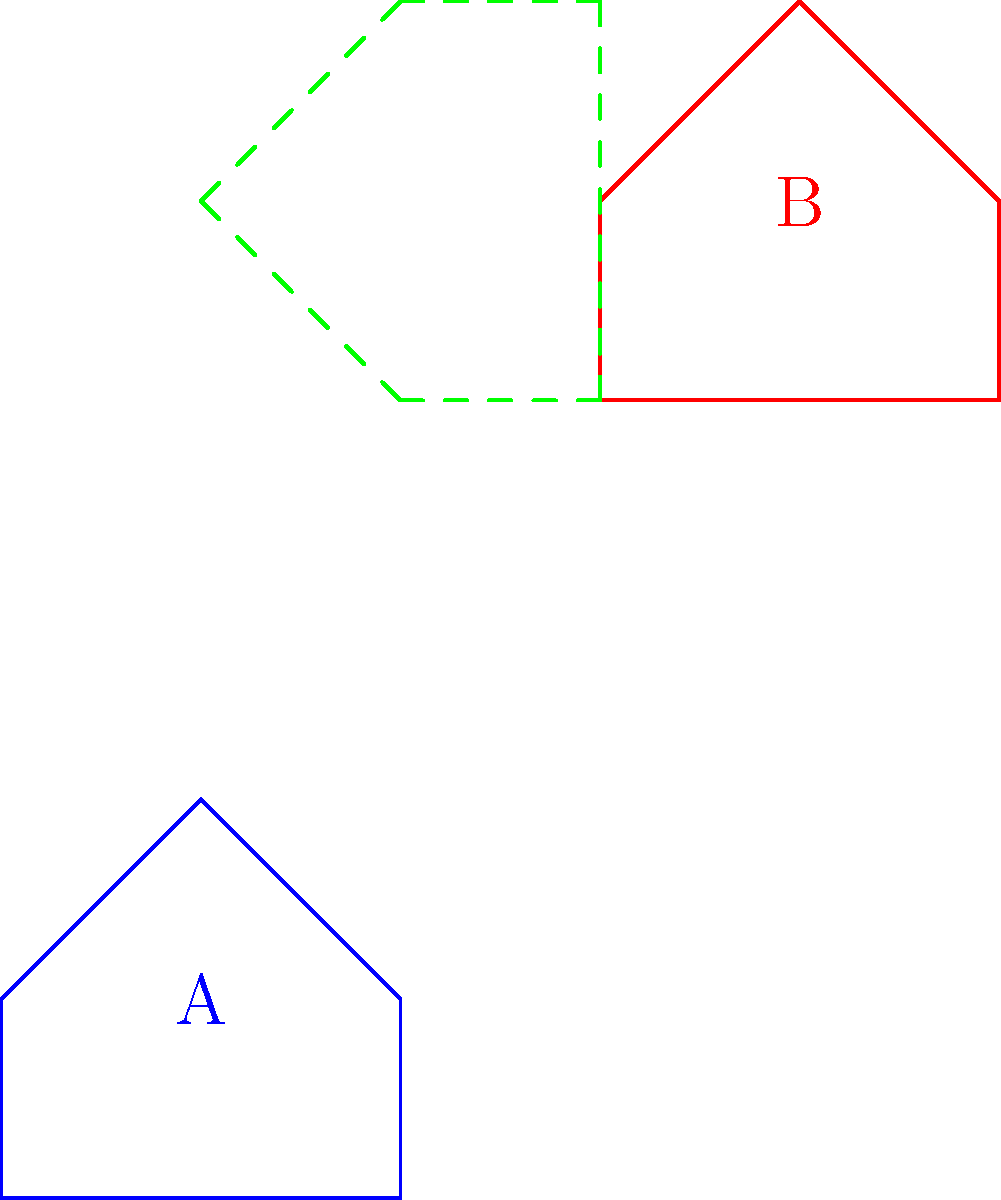Alright, you mathematical mastermind! Let's see if you can crack this transformational conundrum. Given two irregular pentagons A (blue) and B (red), determine the sequence of transformations needed to map A onto B. Express your answer as a composition of functions, where $T$ represents translation, $R$ represents rotation, and $S$ represents scaling. Use appropriate parameters for each transformation. Let's break this down step by step, you sassy geometry genius:

1) First, observe that B is clearly larger than A, so we'll need a scaling transformation.
   The scaling factor appears to be 1, as the side lengths are preserved.

2) Next, notice that B is rotated 90° clockwise relative to A.
   In our composition, this will be represented as a 90° counterclockwise rotation.

3) Finally, B is translated relative to A. The translation appears to move the origin of A to (3,4).

4) To express this as a composition of functions, we start with the innermost transformation (scaling) and work our way out:

   a) Scale: $S(1)$ (scaling by a factor of 1)
   b) Rotate: $R(90°)$ (rotating 90° counterclockwise)
   c) Translate: $T((3,4))$ (translating by vector (3,4))

5) Composing these functions, we get: $T((3,4)) \circ R(90°) \circ S(1)$

This composition, when applied to A, will map it onto B.
Answer: $T((3,4)) \circ R(90°) \circ S(1)$ 